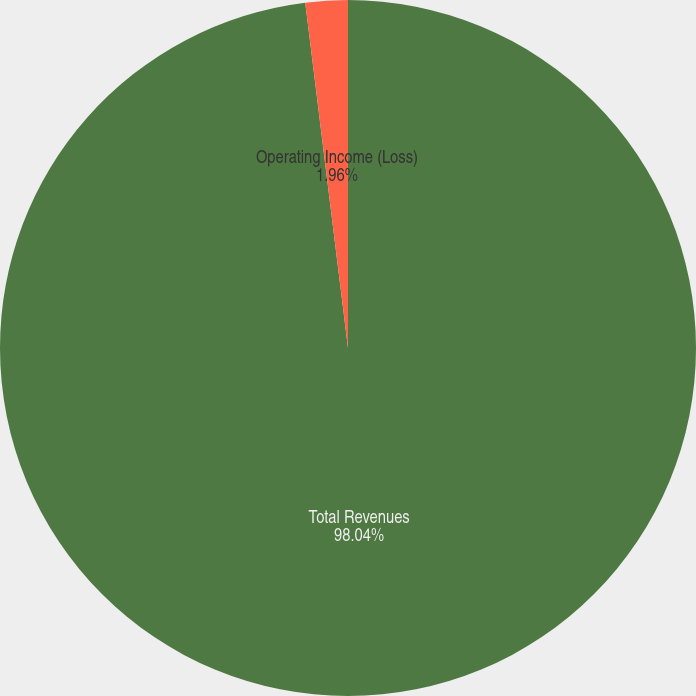<chart> <loc_0><loc_0><loc_500><loc_500><pie_chart><fcel>Total Revenues<fcel>Operating Income (Loss)<nl><fcel>98.04%<fcel>1.96%<nl></chart> 